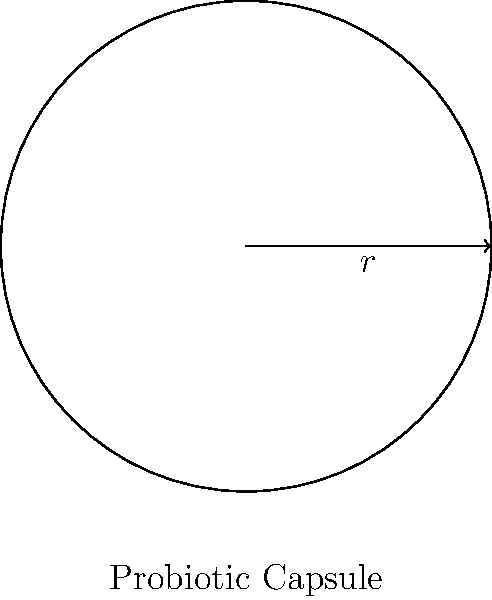As a functional medicine practitioner, you're designing a new probiotic supplement. The capsule is spherical with a radius of 5 mm. Calculate the surface area of this probiotic capsule in square millimeters. Round your answer to two decimal places. To calculate the surface area of a sphere, we use the formula:

$$ A = 4\pi r^2 $$

Where:
$A$ is the surface area
$r$ is the radius of the sphere

Given:
$r = 5$ mm

Step 1: Substitute the radius into the formula
$$ A = 4\pi (5\text{ mm})^2 $$

Step 2: Calculate the square of the radius
$$ A = 4\pi (25\text{ mm}^2) $$

Step 3: Multiply by $4\pi$
$$ A = 100\pi\text{ mm}^2 $$

Step 4: Calculate the final value (π ≈ 3.14159)
$$ A = 100 \times 3.14159\text{ mm}^2 = 314.159\text{ mm}^2 $$

Step 5: Round to two decimal places
$$ A \approx 314.16\text{ mm}^2 $$
Answer: $314.16\text{ mm}^2$ 